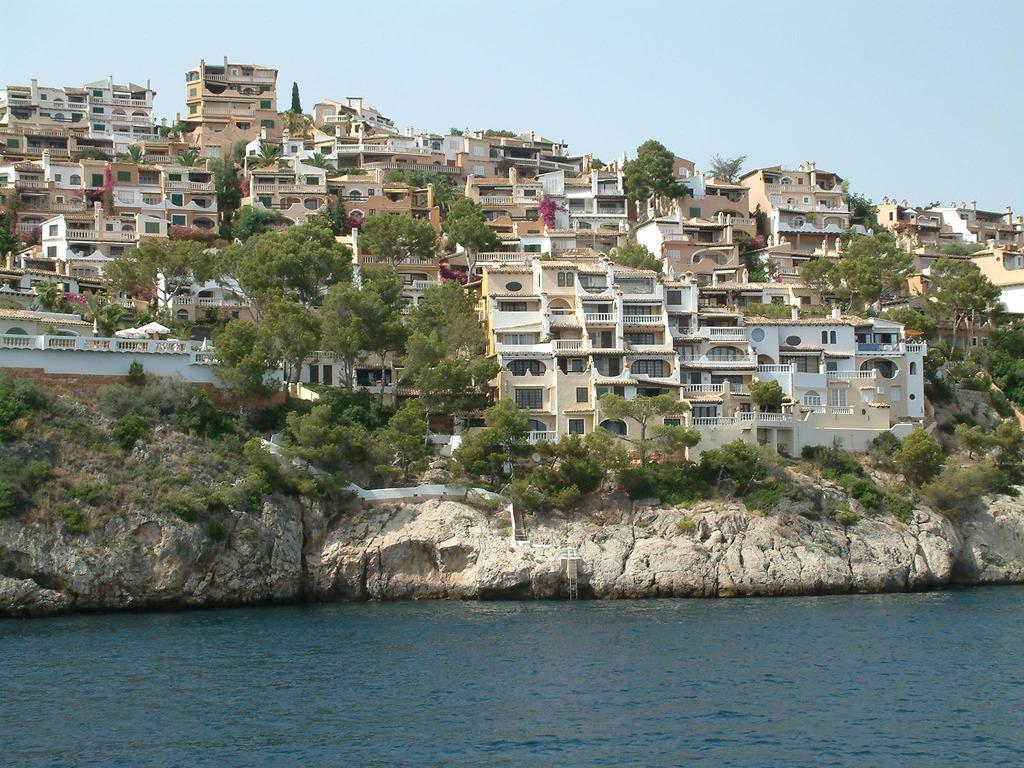Please provide a concise description of this image. At the bottom of this image I can see the water. In the middle of the image there are many buildings, trees and rocks. At the top of the image I can see the sky. 